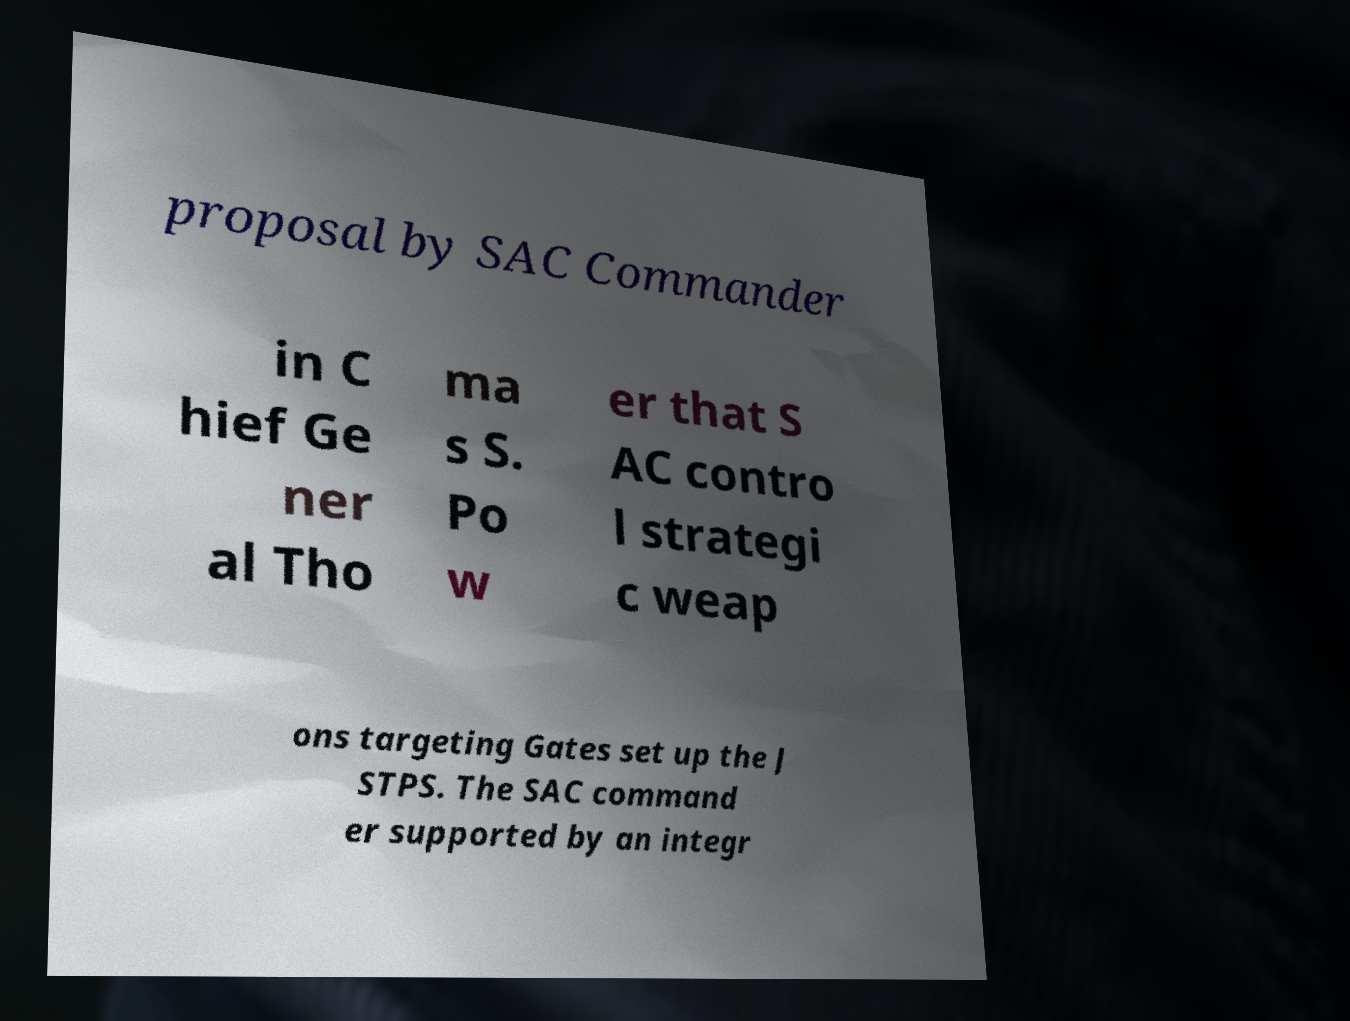Could you extract and type out the text from this image? proposal by SAC Commander in C hief Ge ner al Tho ma s S. Po w er that S AC contro l strategi c weap ons targeting Gates set up the J STPS. The SAC command er supported by an integr 